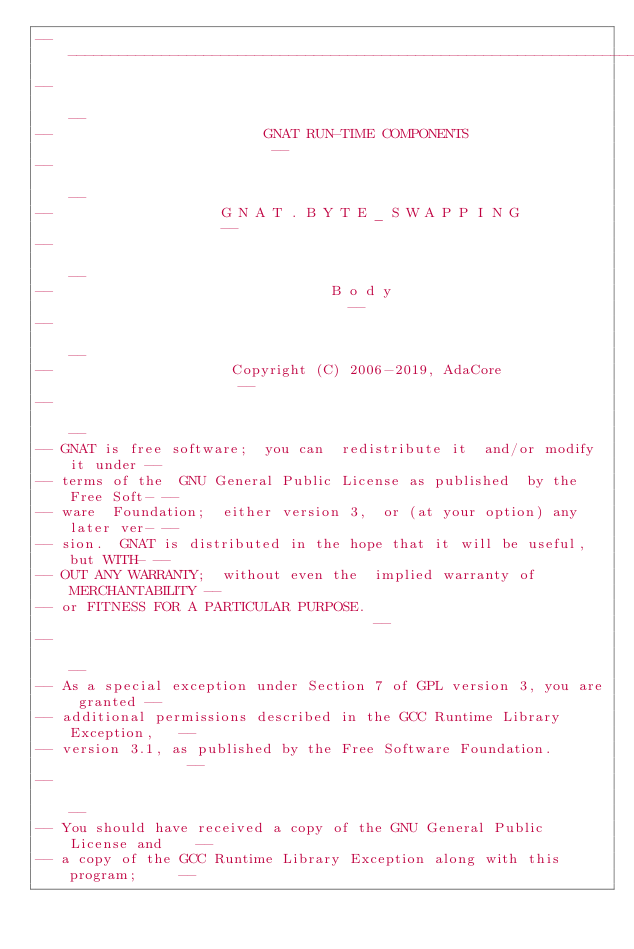<code> <loc_0><loc_0><loc_500><loc_500><_Ada_>------------------------------------------------------------------------------
--                                                                          --
--                         GNAT RUN-TIME COMPONENTS                         --
--                                                                          --
--                    G N A T . B Y T E _ S W A P P I N G                   --
--                                                                          --
--                                 B o d y                                  --
--                                                                          --
--                     Copyright (C) 2006-2019, AdaCore                     --
--                                                                          --
-- GNAT is free software;  you can  redistribute it  and/or modify it under --
-- terms of the  GNU General Public License as published  by the Free Soft- --
-- ware  Foundation;  either version 3,  or (at your option) any later ver- --
-- sion.  GNAT is distributed in the hope that it will be useful, but WITH- --
-- OUT ANY WARRANTY;  without even the  implied warranty of MERCHANTABILITY --
-- or FITNESS FOR A PARTICULAR PURPOSE.                                     --
--                                                                          --
-- As a special exception under Section 7 of GPL version 3, you are granted --
-- additional permissions described in the GCC Runtime Library Exception,   --
-- version 3.1, as published by the Free Software Foundation.               --
--                                                                          --
-- You should have received a copy of the GNU General Public License and    --
-- a copy of the GCC Runtime Library Exception along with this program;     --</code> 